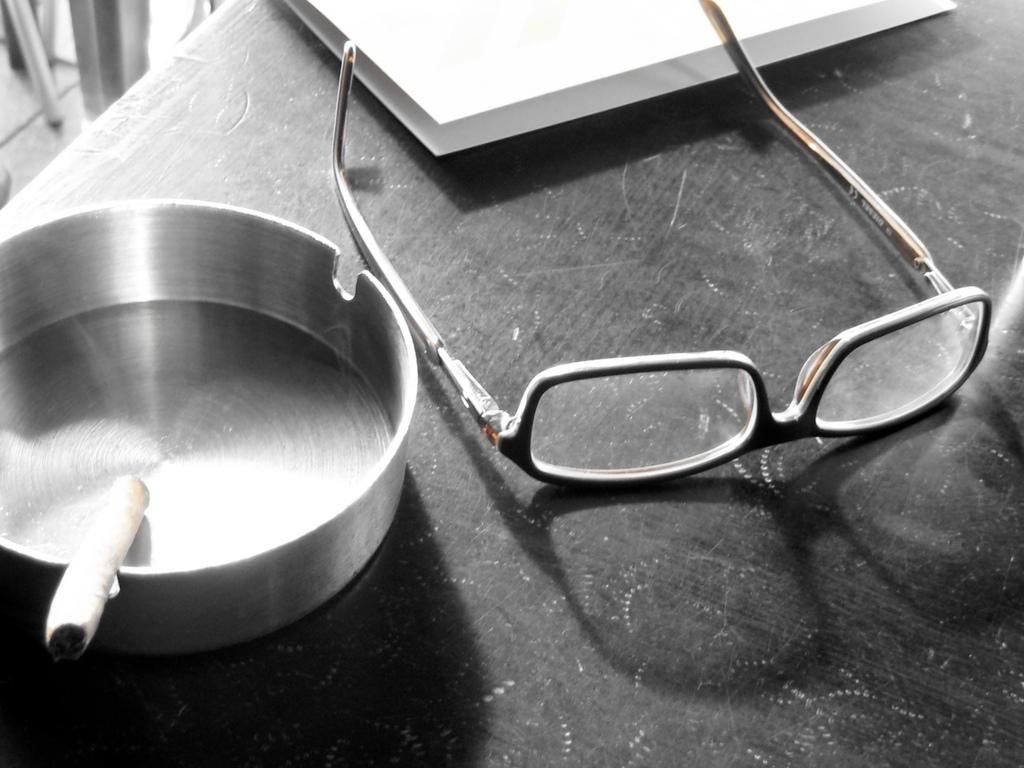What type of accessory is present in the image? There are spectacles in the image. What is the smoking-related item in the image? There is a cigarette in the image. What is used for holding cigarette ashes in the image? There is an ashtray in the image. What is the color of the table in the image? The table in the image is black in color. What other objects can be seen on the table in the image? There are other objects on the table, but their specific details are not mentioned in the provided facts. What type of leather material is used for the spectacles in the image? There is no mention of leather material in the image or the provided facts. The spectacles are not described in terms of their material composition. 